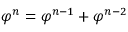Convert formula to latex. <formula><loc_0><loc_0><loc_500><loc_500>\varphi ^ { n } = \varphi ^ { n - 1 } + \varphi ^ { n - 2 }</formula> 